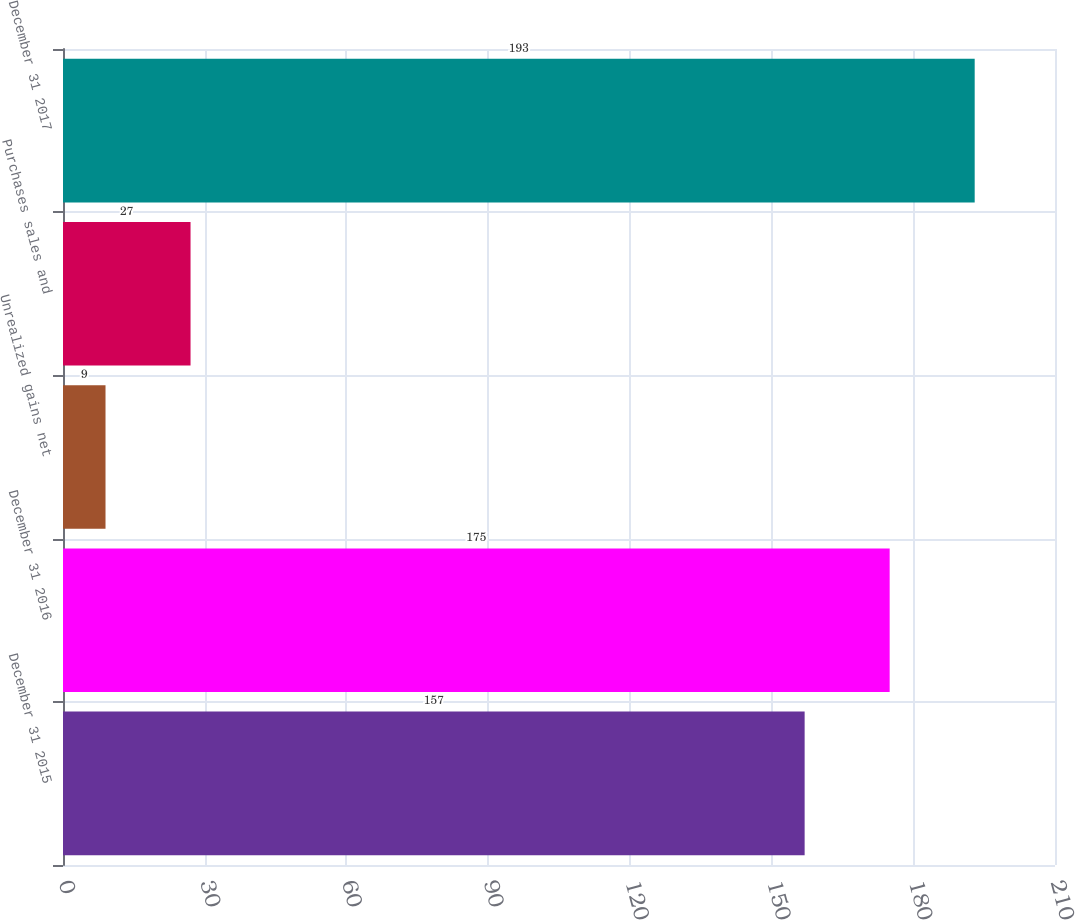Convert chart. <chart><loc_0><loc_0><loc_500><loc_500><bar_chart><fcel>December 31 2015<fcel>December 31 2016<fcel>Unrealized gains net<fcel>Purchases sales and<fcel>December 31 2017<nl><fcel>157<fcel>175<fcel>9<fcel>27<fcel>193<nl></chart> 